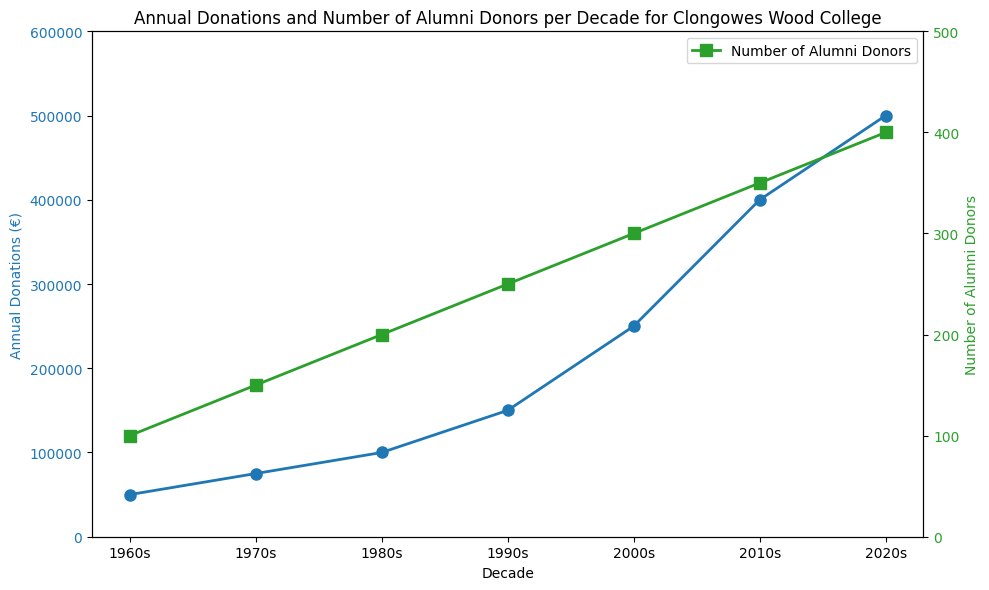What is the total annual donation for the 1960s and 1970s combined? To find the total annual donation for the 1960s and 1970s, add the donations for these decades. 50,000 (1960s) + 75,000 (1970s) = 125,000.
Answer: 125,000 Which decade had the highest number of alumni donors? To determine the decade with the highest number of alumni donors, look at the "Number of Alumni Donors" plot and identify the data point with the highest value. The 2020s had 400 donors, which is the highest.
Answer: 2020s How many more alumni donors were there in the 2020s compared to the 1960s? To find the difference in the number of alumni donors between the 2020s and the 1960s, subtract the number of donors in the 1960s from that in the 2020s. 400 (2020s) - 100 (1960s) = 300.
Answer: 300 What is the average number of alumni donors per decade? To find the average number of alumni donors per decade, sum all the donors and divide by the number of decades. (100 + 150 + 200 + 250 + 300 + 350 + 400) / 7 = 1750 / 7 ≈ 250.
Answer: 250 In which decade did the annual donations exceed 200,000 euros for the first time? To determine when donations first exceeded 200,000 euros, look at the "Annual Donations (€)" plot to find the first data point above 200,000. This occurred in the 2000s with 250,000 euros.
Answer: 2000s By how much did the annual donations increase from the 1980s to the 1990s? To find the increase in donations from the 1980s to the 1990s, subtract the donation amount of the 1980s from that of the 1990s. 150,000 (1990s) - 100,000 (1980s) = 50,000.
Answer: 50,000 What trend do you observe in the annual donations and the number of alumni donors across the decades? Observing both plots, it is clear that both annual donations and the number of alumni donors steadily increase from the 1960s to the 2020s.
Answer: Steady increase 